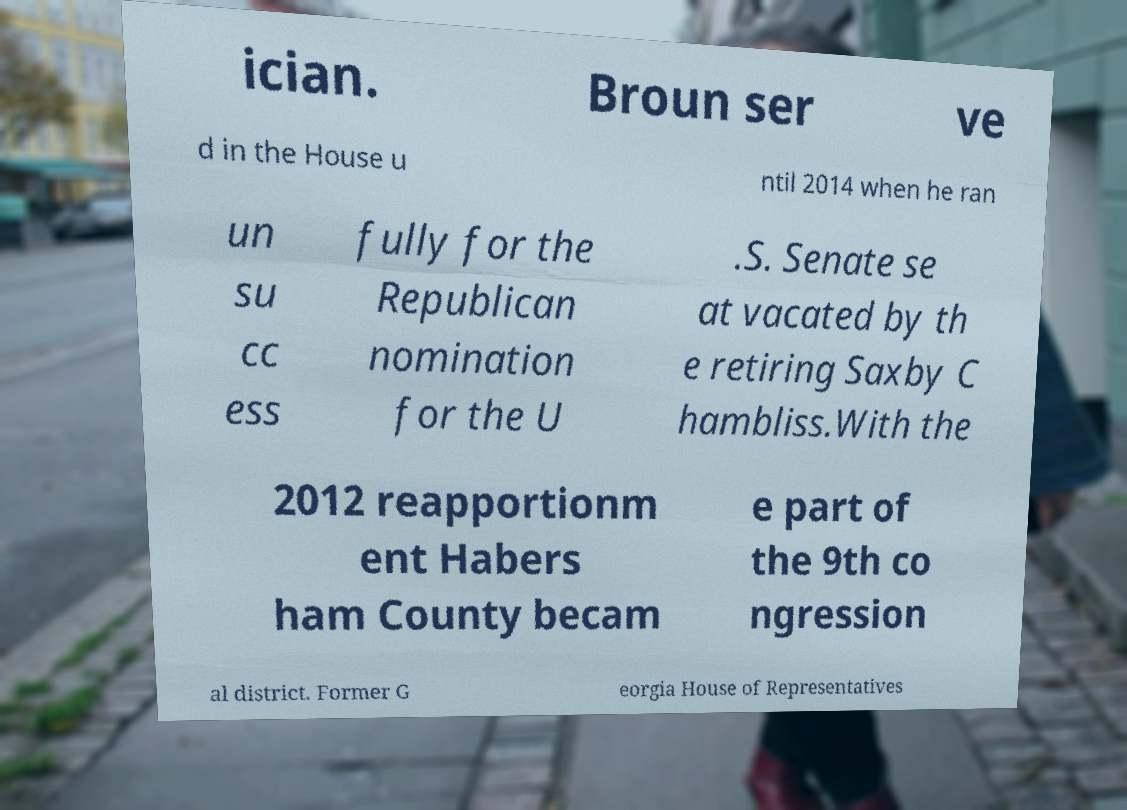Can you read and provide the text displayed in the image?This photo seems to have some interesting text. Can you extract and type it out for me? ician. Broun ser ve d in the House u ntil 2014 when he ran un su cc ess fully for the Republican nomination for the U .S. Senate se at vacated by th e retiring Saxby C hambliss.With the 2012 reapportionm ent Habers ham County becam e part of the 9th co ngression al district. Former G eorgia House of Representatives 